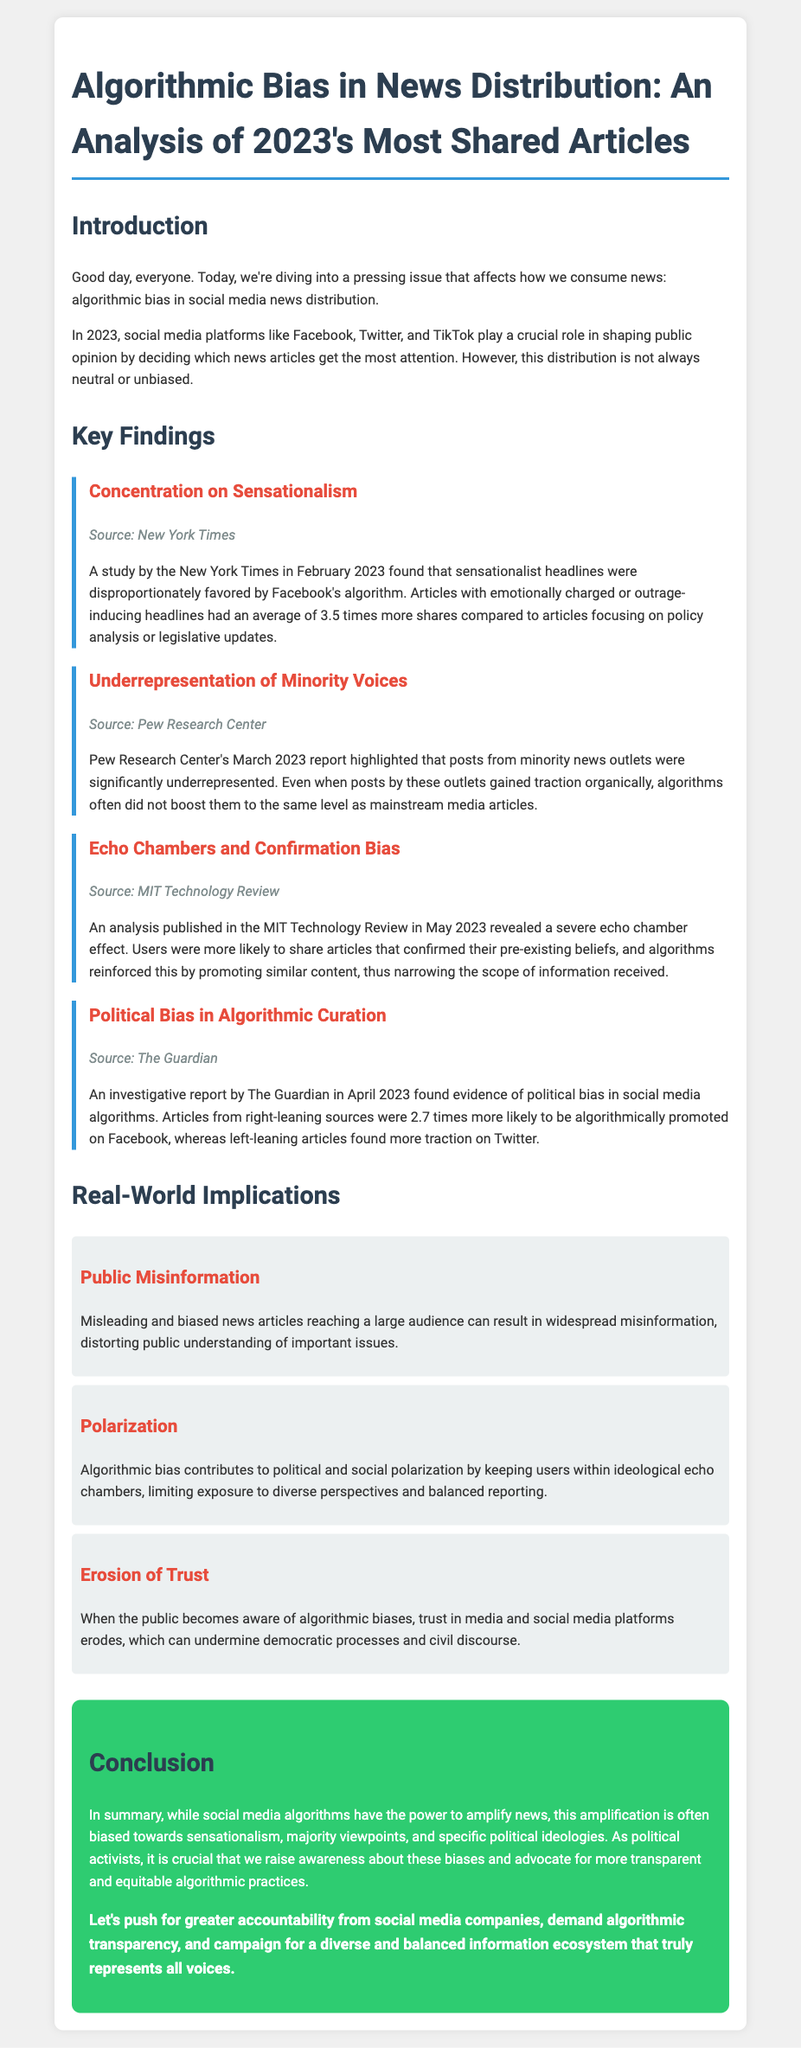What is the title of the document? The title is provided at the beginning of the document and summarizes the main focus of the analysis.
Answer: Algorithmic Bias in News Distribution: An Analysis of 2023's Most Shared Articles Which social media platform was found to favor sensationalist headlines? The document specifically mentions a study that identifies Facebook's preference for sensationalist content.
Answer: Facebook What is the average share increase for sensationalist articles? The document states that sensationalist articles had significantly more shares, quantifying the increase as an average.
Answer: 3.5 times What type of news outlets were underrepresented according to the Pew Research Center? The document specifies minority news outlets as the group that faced underrepresentation.
Answer: Minority voices According to the MIT Technology Review, what effect did algorithms have on users sharing articles? This question pertains to the impact of algorithms on users' behavior in sharing content, as documented in the analysis.
Answer: Echo chamber effect What political bias did The Guardian report regarding algorithmic promotion? The document describes how certain political leanings affected the likelihood of algorithmic promotion on social media platforms.
Answer: Political bias What is a consequence of algorithmic bias mentioned in the document? This question asks for a real-world implication of the findings discussed in the document.
Answer: Public misinformation What should activists push for regarding social media companies, according to the conclusion? The conclusion calls for specific actions that activists should undertake to address the issues highlighted in the analysis.
Answer: Algorithmic transparency 